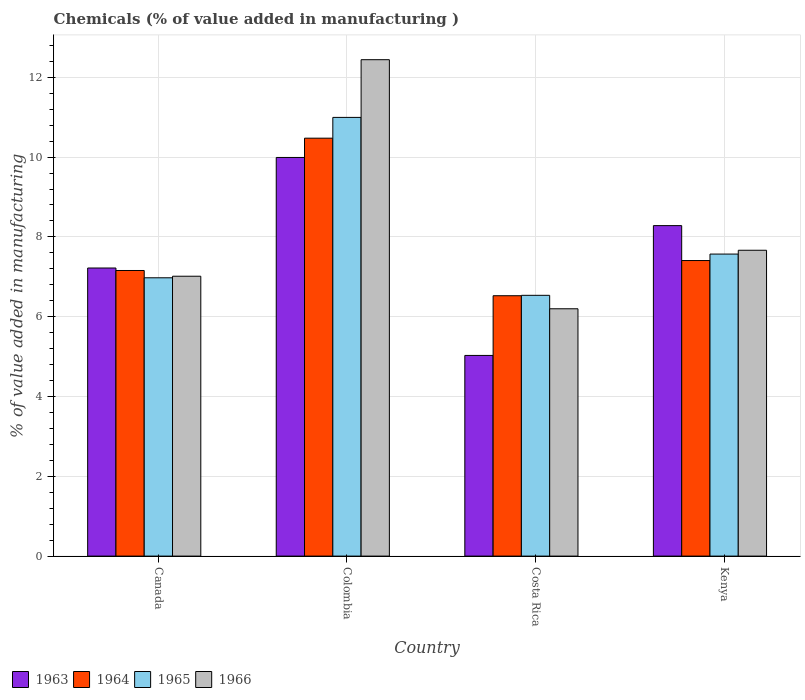Are the number of bars per tick equal to the number of legend labels?
Make the answer very short. Yes. Are the number of bars on each tick of the X-axis equal?
Give a very brief answer. Yes. How many bars are there on the 4th tick from the left?
Offer a terse response. 4. How many bars are there on the 3rd tick from the right?
Provide a short and direct response. 4. What is the label of the 2nd group of bars from the left?
Your answer should be very brief. Colombia. What is the value added in manufacturing chemicals in 1964 in Canada?
Make the answer very short. 7.16. Across all countries, what is the maximum value added in manufacturing chemicals in 1964?
Offer a terse response. 10.47. Across all countries, what is the minimum value added in manufacturing chemicals in 1963?
Your answer should be very brief. 5.03. What is the total value added in manufacturing chemicals in 1966 in the graph?
Provide a succinct answer. 33.32. What is the difference between the value added in manufacturing chemicals in 1966 in Canada and that in Colombia?
Offer a terse response. -5.43. What is the difference between the value added in manufacturing chemicals in 1964 in Canada and the value added in manufacturing chemicals in 1966 in Colombia?
Keep it short and to the point. -5.28. What is the average value added in manufacturing chemicals in 1964 per country?
Offer a terse response. 7.89. What is the difference between the value added in manufacturing chemicals of/in 1963 and value added in manufacturing chemicals of/in 1964 in Kenya?
Provide a succinct answer. 0.87. What is the ratio of the value added in manufacturing chemicals in 1965 in Colombia to that in Kenya?
Ensure brevity in your answer.  1.45. Is the difference between the value added in manufacturing chemicals in 1963 in Colombia and Kenya greater than the difference between the value added in manufacturing chemicals in 1964 in Colombia and Kenya?
Provide a short and direct response. No. What is the difference between the highest and the second highest value added in manufacturing chemicals in 1966?
Offer a very short reply. -5.43. What is the difference between the highest and the lowest value added in manufacturing chemicals in 1963?
Your response must be concise. 4.96. In how many countries, is the value added in manufacturing chemicals in 1966 greater than the average value added in manufacturing chemicals in 1966 taken over all countries?
Offer a very short reply. 1. What does the 1st bar from the right in Canada represents?
Offer a terse response. 1966. Is it the case that in every country, the sum of the value added in manufacturing chemicals in 1966 and value added in manufacturing chemicals in 1963 is greater than the value added in manufacturing chemicals in 1965?
Provide a short and direct response. Yes. How many bars are there?
Your answer should be very brief. 16. What is the difference between two consecutive major ticks on the Y-axis?
Your response must be concise. 2. Does the graph contain any zero values?
Provide a succinct answer. No. Does the graph contain grids?
Make the answer very short. Yes. How are the legend labels stacked?
Provide a succinct answer. Horizontal. What is the title of the graph?
Provide a short and direct response. Chemicals (% of value added in manufacturing ). Does "1977" appear as one of the legend labels in the graph?
Make the answer very short. No. What is the label or title of the X-axis?
Your answer should be very brief. Country. What is the label or title of the Y-axis?
Offer a very short reply. % of value added in manufacturing. What is the % of value added in manufacturing of 1963 in Canada?
Provide a short and direct response. 7.22. What is the % of value added in manufacturing of 1964 in Canada?
Provide a succinct answer. 7.16. What is the % of value added in manufacturing in 1965 in Canada?
Offer a very short reply. 6.98. What is the % of value added in manufacturing in 1966 in Canada?
Offer a terse response. 7.01. What is the % of value added in manufacturing of 1963 in Colombia?
Ensure brevity in your answer.  9.99. What is the % of value added in manufacturing in 1964 in Colombia?
Make the answer very short. 10.47. What is the % of value added in manufacturing in 1965 in Colombia?
Ensure brevity in your answer.  10.99. What is the % of value added in manufacturing in 1966 in Colombia?
Offer a very short reply. 12.44. What is the % of value added in manufacturing of 1963 in Costa Rica?
Your response must be concise. 5.03. What is the % of value added in manufacturing in 1964 in Costa Rica?
Give a very brief answer. 6.53. What is the % of value added in manufacturing of 1965 in Costa Rica?
Offer a terse response. 6.54. What is the % of value added in manufacturing in 1966 in Costa Rica?
Your answer should be compact. 6.2. What is the % of value added in manufacturing in 1963 in Kenya?
Provide a succinct answer. 8.28. What is the % of value added in manufacturing in 1964 in Kenya?
Provide a short and direct response. 7.41. What is the % of value added in manufacturing in 1965 in Kenya?
Provide a short and direct response. 7.57. What is the % of value added in manufacturing of 1966 in Kenya?
Your response must be concise. 7.67. Across all countries, what is the maximum % of value added in manufacturing in 1963?
Keep it short and to the point. 9.99. Across all countries, what is the maximum % of value added in manufacturing of 1964?
Offer a terse response. 10.47. Across all countries, what is the maximum % of value added in manufacturing of 1965?
Make the answer very short. 10.99. Across all countries, what is the maximum % of value added in manufacturing of 1966?
Provide a succinct answer. 12.44. Across all countries, what is the minimum % of value added in manufacturing in 1963?
Provide a succinct answer. 5.03. Across all countries, what is the minimum % of value added in manufacturing of 1964?
Your answer should be compact. 6.53. Across all countries, what is the minimum % of value added in manufacturing of 1965?
Make the answer very short. 6.54. Across all countries, what is the minimum % of value added in manufacturing of 1966?
Keep it short and to the point. 6.2. What is the total % of value added in manufacturing in 1963 in the graph?
Your answer should be compact. 30.52. What is the total % of value added in manufacturing in 1964 in the graph?
Provide a short and direct response. 31.57. What is the total % of value added in manufacturing of 1965 in the graph?
Provide a succinct answer. 32.08. What is the total % of value added in manufacturing in 1966 in the graph?
Give a very brief answer. 33.32. What is the difference between the % of value added in manufacturing in 1963 in Canada and that in Colombia?
Your response must be concise. -2.77. What is the difference between the % of value added in manufacturing of 1964 in Canada and that in Colombia?
Your answer should be compact. -3.32. What is the difference between the % of value added in manufacturing of 1965 in Canada and that in Colombia?
Offer a terse response. -4.02. What is the difference between the % of value added in manufacturing in 1966 in Canada and that in Colombia?
Keep it short and to the point. -5.43. What is the difference between the % of value added in manufacturing of 1963 in Canada and that in Costa Rica?
Your response must be concise. 2.19. What is the difference between the % of value added in manufacturing of 1964 in Canada and that in Costa Rica?
Offer a terse response. 0.63. What is the difference between the % of value added in manufacturing of 1965 in Canada and that in Costa Rica?
Keep it short and to the point. 0.44. What is the difference between the % of value added in manufacturing of 1966 in Canada and that in Costa Rica?
Give a very brief answer. 0.82. What is the difference between the % of value added in manufacturing in 1963 in Canada and that in Kenya?
Your answer should be very brief. -1.06. What is the difference between the % of value added in manufacturing in 1964 in Canada and that in Kenya?
Offer a terse response. -0.25. What is the difference between the % of value added in manufacturing in 1965 in Canada and that in Kenya?
Your answer should be compact. -0.59. What is the difference between the % of value added in manufacturing of 1966 in Canada and that in Kenya?
Your response must be concise. -0.65. What is the difference between the % of value added in manufacturing of 1963 in Colombia and that in Costa Rica?
Keep it short and to the point. 4.96. What is the difference between the % of value added in manufacturing of 1964 in Colombia and that in Costa Rica?
Provide a short and direct response. 3.95. What is the difference between the % of value added in manufacturing in 1965 in Colombia and that in Costa Rica?
Offer a very short reply. 4.46. What is the difference between the % of value added in manufacturing in 1966 in Colombia and that in Costa Rica?
Your answer should be very brief. 6.24. What is the difference between the % of value added in manufacturing of 1963 in Colombia and that in Kenya?
Your answer should be very brief. 1.71. What is the difference between the % of value added in manufacturing in 1964 in Colombia and that in Kenya?
Offer a very short reply. 3.07. What is the difference between the % of value added in manufacturing of 1965 in Colombia and that in Kenya?
Offer a very short reply. 3.43. What is the difference between the % of value added in manufacturing in 1966 in Colombia and that in Kenya?
Keep it short and to the point. 4.78. What is the difference between the % of value added in manufacturing in 1963 in Costa Rica and that in Kenya?
Ensure brevity in your answer.  -3.25. What is the difference between the % of value added in manufacturing of 1964 in Costa Rica and that in Kenya?
Give a very brief answer. -0.88. What is the difference between the % of value added in manufacturing of 1965 in Costa Rica and that in Kenya?
Provide a succinct answer. -1.03. What is the difference between the % of value added in manufacturing of 1966 in Costa Rica and that in Kenya?
Offer a terse response. -1.47. What is the difference between the % of value added in manufacturing in 1963 in Canada and the % of value added in manufacturing in 1964 in Colombia?
Provide a short and direct response. -3.25. What is the difference between the % of value added in manufacturing in 1963 in Canada and the % of value added in manufacturing in 1965 in Colombia?
Keep it short and to the point. -3.77. What is the difference between the % of value added in manufacturing in 1963 in Canada and the % of value added in manufacturing in 1966 in Colombia?
Ensure brevity in your answer.  -5.22. What is the difference between the % of value added in manufacturing in 1964 in Canada and the % of value added in manufacturing in 1965 in Colombia?
Keep it short and to the point. -3.84. What is the difference between the % of value added in manufacturing of 1964 in Canada and the % of value added in manufacturing of 1966 in Colombia?
Your answer should be very brief. -5.28. What is the difference between the % of value added in manufacturing of 1965 in Canada and the % of value added in manufacturing of 1966 in Colombia?
Your response must be concise. -5.47. What is the difference between the % of value added in manufacturing of 1963 in Canada and the % of value added in manufacturing of 1964 in Costa Rica?
Your answer should be very brief. 0.69. What is the difference between the % of value added in manufacturing in 1963 in Canada and the % of value added in manufacturing in 1965 in Costa Rica?
Make the answer very short. 0.68. What is the difference between the % of value added in manufacturing in 1963 in Canada and the % of value added in manufacturing in 1966 in Costa Rica?
Offer a terse response. 1.02. What is the difference between the % of value added in manufacturing of 1964 in Canada and the % of value added in manufacturing of 1965 in Costa Rica?
Give a very brief answer. 0.62. What is the difference between the % of value added in manufacturing of 1964 in Canada and the % of value added in manufacturing of 1966 in Costa Rica?
Give a very brief answer. 0.96. What is the difference between the % of value added in manufacturing in 1965 in Canada and the % of value added in manufacturing in 1966 in Costa Rica?
Your answer should be compact. 0.78. What is the difference between the % of value added in manufacturing in 1963 in Canada and the % of value added in manufacturing in 1964 in Kenya?
Make the answer very short. -0.19. What is the difference between the % of value added in manufacturing in 1963 in Canada and the % of value added in manufacturing in 1965 in Kenya?
Keep it short and to the point. -0.35. What is the difference between the % of value added in manufacturing of 1963 in Canada and the % of value added in manufacturing of 1966 in Kenya?
Make the answer very short. -0.44. What is the difference between the % of value added in manufacturing of 1964 in Canada and the % of value added in manufacturing of 1965 in Kenya?
Offer a terse response. -0.41. What is the difference between the % of value added in manufacturing in 1964 in Canada and the % of value added in manufacturing in 1966 in Kenya?
Provide a succinct answer. -0.51. What is the difference between the % of value added in manufacturing of 1965 in Canada and the % of value added in manufacturing of 1966 in Kenya?
Your answer should be compact. -0.69. What is the difference between the % of value added in manufacturing of 1963 in Colombia and the % of value added in manufacturing of 1964 in Costa Rica?
Make the answer very short. 3.47. What is the difference between the % of value added in manufacturing in 1963 in Colombia and the % of value added in manufacturing in 1965 in Costa Rica?
Provide a succinct answer. 3.46. What is the difference between the % of value added in manufacturing of 1963 in Colombia and the % of value added in manufacturing of 1966 in Costa Rica?
Provide a succinct answer. 3.79. What is the difference between the % of value added in manufacturing in 1964 in Colombia and the % of value added in manufacturing in 1965 in Costa Rica?
Provide a short and direct response. 3.94. What is the difference between the % of value added in manufacturing of 1964 in Colombia and the % of value added in manufacturing of 1966 in Costa Rica?
Give a very brief answer. 4.28. What is the difference between the % of value added in manufacturing of 1965 in Colombia and the % of value added in manufacturing of 1966 in Costa Rica?
Keep it short and to the point. 4.8. What is the difference between the % of value added in manufacturing of 1963 in Colombia and the % of value added in manufacturing of 1964 in Kenya?
Keep it short and to the point. 2.58. What is the difference between the % of value added in manufacturing of 1963 in Colombia and the % of value added in manufacturing of 1965 in Kenya?
Make the answer very short. 2.42. What is the difference between the % of value added in manufacturing of 1963 in Colombia and the % of value added in manufacturing of 1966 in Kenya?
Offer a terse response. 2.33. What is the difference between the % of value added in manufacturing in 1964 in Colombia and the % of value added in manufacturing in 1965 in Kenya?
Your answer should be very brief. 2.9. What is the difference between the % of value added in manufacturing of 1964 in Colombia and the % of value added in manufacturing of 1966 in Kenya?
Keep it short and to the point. 2.81. What is the difference between the % of value added in manufacturing of 1965 in Colombia and the % of value added in manufacturing of 1966 in Kenya?
Your answer should be compact. 3.33. What is the difference between the % of value added in manufacturing in 1963 in Costa Rica and the % of value added in manufacturing in 1964 in Kenya?
Provide a succinct answer. -2.38. What is the difference between the % of value added in manufacturing in 1963 in Costa Rica and the % of value added in manufacturing in 1965 in Kenya?
Your answer should be compact. -2.54. What is the difference between the % of value added in manufacturing of 1963 in Costa Rica and the % of value added in manufacturing of 1966 in Kenya?
Make the answer very short. -2.64. What is the difference between the % of value added in manufacturing in 1964 in Costa Rica and the % of value added in manufacturing in 1965 in Kenya?
Provide a short and direct response. -1.04. What is the difference between the % of value added in manufacturing of 1964 in Costa Rica and the % of value added in manufacturing of 1966 in Kenya?
Offer a very short reply. -1.14. What is the difference between the % of value added in manufacturing of 1965 in Costa Rica and the % of value added in manufacturing of 1966 in Kenya?
Your answer should be very brief. -1.13. What is the average % of value added in manufacturing of 1963 per country?
Provide a short and direct response. 7.63. What is the average % of value added in manufacturing in 1964 per country?
Keep it short and to the point. 7.89. What is the average % of value added in manufacturing in 1965 per country?
Keep it short and to the point. 8.02. What is the average % of value added in manufacturing of 1966 per country?
Provide a succinct answer. 8.33. What is the difference between the % of value added in manufacturing of 1963 and % of value added in manufacturing of 1964 in Canada?
Keep it short and to the point. 0.06. What is the difference between the % of value added in manufacturing of 1963 and % of value added in manufacturing of 1965 in Canada?
Your answer should be compact. 0.25. What is the difference between the % of value added in manufacturing in 1963 and % of value added in manufacturing in 1966 in Canada?
Give a very brief answer. 0.21. What is the difference between the % of value added in manufacturing of 1964 and % of value added in manufacturing of 1965 in Canada?
Your response must be concise. 0.18. What is the difference between the % of value added in manufacturing in 1964 and % of value added in manufacturing in 1966 in Canada?
Provide a short and direct response. 0.14. What is the difference between the % of value added in manufacturing in 1965 and % of value added in manufacturing in 1966 in Canada?
Keep it short and to the point. -0.04. What is the difference between the % of value added in manufacturing of 1963 and % of value added in manufacturing of 1964 in Colombia?
Your response must be concise. -0.48. What is the difference between the % of value added in manufacturing in 1963 and % of value added in manufacturing in 1965 in Colombia?
Ensure brevity in your answer.  -1. What is the difference between the % of value added in manufacturing in 1963 and % of value added in manufacturing in 1966 in Colombia?
Ensure brevity in your answer.  -2.45. What is the difference between the % of value added in manufacturing of 1964 and % of value added in manufacturing of 1965 in Colombia?
Make the answer very short. -0.52. What is the difference between the % of value added in manufacturing in 1964 and % of value added in manufacturing in 1966 in Colombia?
Offer a very short reply. -1.97. What is the difference between the % of value added in manufacturing in 1965 and % of value added in manufacturing in 1966 in Colombia?
Your response must be concise. -1.45. What is the difference between the % of value added in manufacturing of 1963 and % of value added in manufacturing of 1964 in Costa Rica?
Your response must be concise. -1.5. What is the difference between the % of value added in manufacturing of 1963 and % of value added in manufacturing of 1965 in Costa Rica?
Ensure brevity in your answer.  -1.51. What is the difference between the % of value added in manufacturing of 1963 and % of value added in manufacturing of 1966 in Costa Rica?
Keep it short and to the point. -1.17. What is the difference between the % of value added in manufacturing in 1964 and % of value added in manufacturing in 1965 in Costa Rica?
Your answer should be very brief. -0.01. What is the difference between the % of value added in manufacturing in 1964 and % of value added in manufacturing in 1966 in Costa Rica?
Keep it short and to the point. 0.33. What is the difference between the % of value added in manufacturing of 1965 and % of value added in manufacturing of 1966 in Costa Rica?
Provide a short and direct response. 0.34. What is the difference between the % of value added in manufacturing of 1963 and % of value added in manufacturing of 1964 in Kenya?
Offer a very short reply. 0.87. What is the difference between the % of value added in manufacturing in 1963 and % of value added in manufacturing in 1965 in Kenya?
Offer a very short reply. 0.71. What is the difference between the % of value added in manufacturing in 1963 and % of value added in manufacturing in 1966 in Kenya?
Your answer should be very brief. 0.62. What is the difference between the % of value added in manufacturing of 1964 and % of value added in manufacturing of 1965 in Kenya?
Offer a very short reply. -0.16. What is the difference between the % of value added in manufacturing in 1964 and % of value added in manufacturing in 1966 in Kenya?
Give a very brief answer. -0.26. What is the difference between the % of value added in manufacturing in 1965 and % of value added in manufacturing in 1966 in Kenya?
Provide a short and direct response. -0.1. What is the ratio of the % of value added in manufacturing in 1963 in Canada to that in Colombia?
Give a very brief answer. 0.72. What is the ratio of the % of value added in manufacturing of 1964 in Canada to that in Colombia?
Your response must be concise. 0.68. What is the ratio of the % of value added in manufacturing in 1965 in Canada to that in Colombia?
Give a very brief answer. 0.63. What is the ratio of the % of value added in manufacturing in 1966 in Canada to that in Colombia?
Give a very brief answer. 0.56. What is the ratio of the % of value added in manufacturing of 1963 in Canada to that in Costa Rica?
Ensure brevity in your answer.  1.44. What is the ratio of the % of value added in manufacturing of 1964 in Canada to that in Costa Rica?
Ensure brevity in your answer.  1.1. What is the ratio of the % of value added in manufacturing of 1965 in Canada to that in Costa Rica?
Keep it short and to the point. 1.07. What is the ratio of the % of value added in manufacturing of 1966 in Canada to that in Costa Rica?
Give a very brief answer. 1.13. What is the ratio of the % of value added in manufacturing of 1963 in Canada to that in Kenya?
Provide a short and direct response. 0.87. What is the ratio of the % of value added in manufacturing in 1964 in Canada to that in Kenya?
Keep it short and to the point. 0.97. What is the ratio of the % of value added in manufacturing of 1965 in Canada to that in Kenya?
Your answer should be compact. 0.92. What is the ratio of the % of value added in manufacturing in 1966 in Canada to that in Kenya?
Offer a very short reply. 0.92. What is the ratio of the % of value added in manufacturing in 1963 in Colombia to that in Costa Rica?
Provide a succinct answer. 1.99. What is the ratio of the % of value added in manufacturing of 1964 in Colombia to that in Costa Rica?
Give a very brief answer. 1.61. What is the ratio of the % of value added in manufacturing in 1965 in Colombia to that in Costa Rica?
Provide a short and direct response. 1.68. What is the ratio of the % of value added in manufacturing of 1966 in Colombia to that in Costa Rica?
Keep it short and to the point. 2.01. What is the ratio of the % of value added in manufacturing of 1963 in Colombia to that in Kenya?
Provide a succinct answer. 1.21. What is the ratio of the % of value added in manufacturing in 1964 in Colombia to that in Kenya?
Offer a very short reply. 1.41. What is the ratio of the % of value added in manufacturing in 1965 in Colombia to that in Kenya?
Keep it short and to the point. 1.45. What is the ratio of the % of value added in manufacturing in 1966 in Colombia to that in Kenya?
Provide a succinct answer. 1.62. What is the ratio of the % of value added in manufacturing in 1963 in Costa Rica to that in Kenya?
Your response must be concise. 0.61. What is the ratio of the % of value added in manufacturing of 1964 in Costa Rica to that in Kenya?
Make the answer very short. 0.88. What is the ratio of the % of value added in manufacturing in 1965 in Costa Rica to that in Kenya?
Keep it short and to the point. 0.86. What is the ratio of the % of value added in manufacturing in 1966 in Costa Rica to that in Kenya?
Give a very brief answer. 0.81. What is the difference between the highest and the second highest % of value added in manufacturing in 1963?
Keep it short and to the point. 1.71. What is the difference between the highest and the second highest % of value added in manufacturing of 1964?
Keep it short and to the point. 3.07. What is the difference between the highest and the second highest % of value added in manufacturing in 1965?
Offer a terse response. 3.43. What is the difference between the highest and the second highest % of value added in manufacturing of 1966?
Provide a succinct answer. 4.78. What is the difference between the highest and the lowest % of value added in manufacturing of 1963?
Your answer should be compact. 4.96. What is the difference between the highest and the lowest % of value added in manufacturing in 1964?
Make the answer very short. 3.95. What is the difference between the highest and the lowest % of value added in manufacturing in 1965?
Provide a succinct answer. 4.46. What is the difference between the highest and the lowest % of value added in manufacturing in 1966?
Your response must be concise. 6.24. 